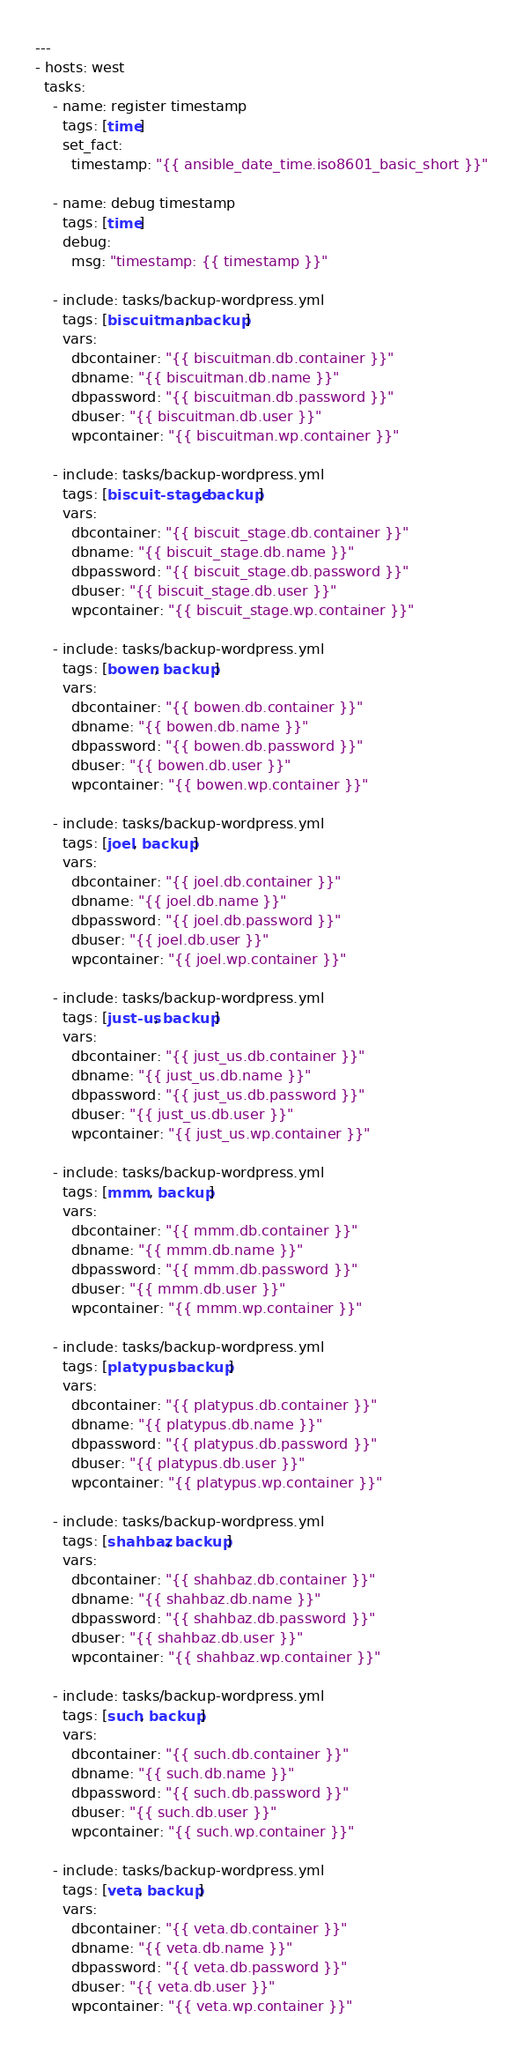Convert code to text. <code><loc_0><loc_0><loc_500><loc_500><_YAML_>---
- hosts: west
  tasks:
    - name: register timestamp
      tags: [time]
      set_fact:
        timestamp: "{{ ansible_date_time.iso8601_basic_short }}"

    - name: debug timestamp
      tags: [time]
      debug:
        msg: "timestamp: {{ timestamp }}"

    - include: tasks/backup-wordpress.yml
      tags: [biscuitman, backup]
      vars:
        dbcontainer: "{{ biscuitman.db.container }}"
        dbname: "{{ biscuitman.db.name }}"
        dbpassword: "{{ biscuitman.db.password }}"
        dbuser: "{{ biscuitman.db.user }}"
        wpcontainer: "{{ biscuitman.wp.container }}"

    - include: tasks/backup-wordpress.yml
      tags: [biscuit-stage, backup]
      vars:
        dbcontainer: "{{ biscuit_stage.db.container }}"
        dbname: "{{ biscuit_stage.db.name }}"
        dbpassword: "{{ biscuit_stage.db.password }}"
        dbuser: "{{ biscuit_stage.db.user }}"
        wpcontainer: "{{ biscuit_stage.wp.container }}"

    - include: tasks/backup-wordpress.yml
      tags: [bowen, backup]
      vars:
        dbcontainer: "{{ bowen.db.container }}"
        dbname: "{{ bowen.db.name }}"
        dbpassword: "{{ bowen.db.password }}"
        dbuser: "{{ bowen.db.user }}"
        wpcontainer: "{{ bowen.wp.container }}"

    - include: tasks/backup-wordpress.yml
      tags: [joel, backup]
      vars:
        dbcontainer: "{{ joel.db.container }}"
        dbname: "{{ joel.db.name }}"
        dbpassword: "{{ joel.db.password }}"
        dbuser: "{{ joel.db.user }}"
        wpcontainer: "{{ joel.wp.container }}"

    - include: tasks/backup-wordpress.yml
      tags: [just-us, backup]
      vars:
        dbcontainer: "{{ just_us.db.container }}"
        dbname: "{{ just_us.db.name }}"
        dbpassword: "{{ just_us.db.password }}"
        dbuser: "{{ just_us.db.user }}"
        wpcontainer: "{{ just_us.wp.container }}"

    - include: tasks/backup-wordpress.yml
      tags: [mmm, backup]
      vars:
        dbcontainer: "{{ mmm.db.container }}"
        dbname: "{{ mmm.db.name }}"
        dbpassword: "{{ mmm.db.password }}"
        dbuser: "{{ mmm.db.user }}"
        wpcontainer: "{{ mmm.wp.container }}"

    - include: tasks/backup-wordpress.yml
      tags: [platypus, backup]
      vars:
        dbcontainer: "{{ platypus.db.container }}"
        dbname: "{{ platypus.db.name }}"
        dbpassword: "{{ platypus.db.password }}"
        dbuser: "{{ platypus.db.user }}"
        wpcontainer: "{{ platypus.wp.container }}"

    - include: tasks/backup-wordpress.yml
      tags: [shahbaz, backup]
      vars:
        dbcontainer: "{{ shahbaz.db.container }}"
        dbname: "{{ shahbaz.db.name }}"
        dbpassword: "{{ shahbaz.db.password }}"
        dbuser: "{{ shahbaz.db.user }}"
        wpcontainer: "{{ shahbaz.wp.container }}"

    - include: tasks/backup-wordpress.yml
      tags: [such, backup]
      vars:
        dbcontainer: "{{ such.db.container }}"
        dbname: "{{ such.db.name }}"
        dbpassword: "{{ such.db.password }}"
        dbuser: "{{ such.db.user }}"
        wpcontainer: "{{ such.wp.container }}"

    - include: tasks/backup-wordpress.yml
      tags: [veta, backup]
      vars:
        dbcontainer: "{{ veta.db.container }}"
        dbname: "{{ veta.db.name }}"
        dbpassword: "{{ veta.db.password }}"
        dbuser: "{{ veta.db.user }}"
        wpcontainer: "{{ veta.wp.container }}"
</code> 